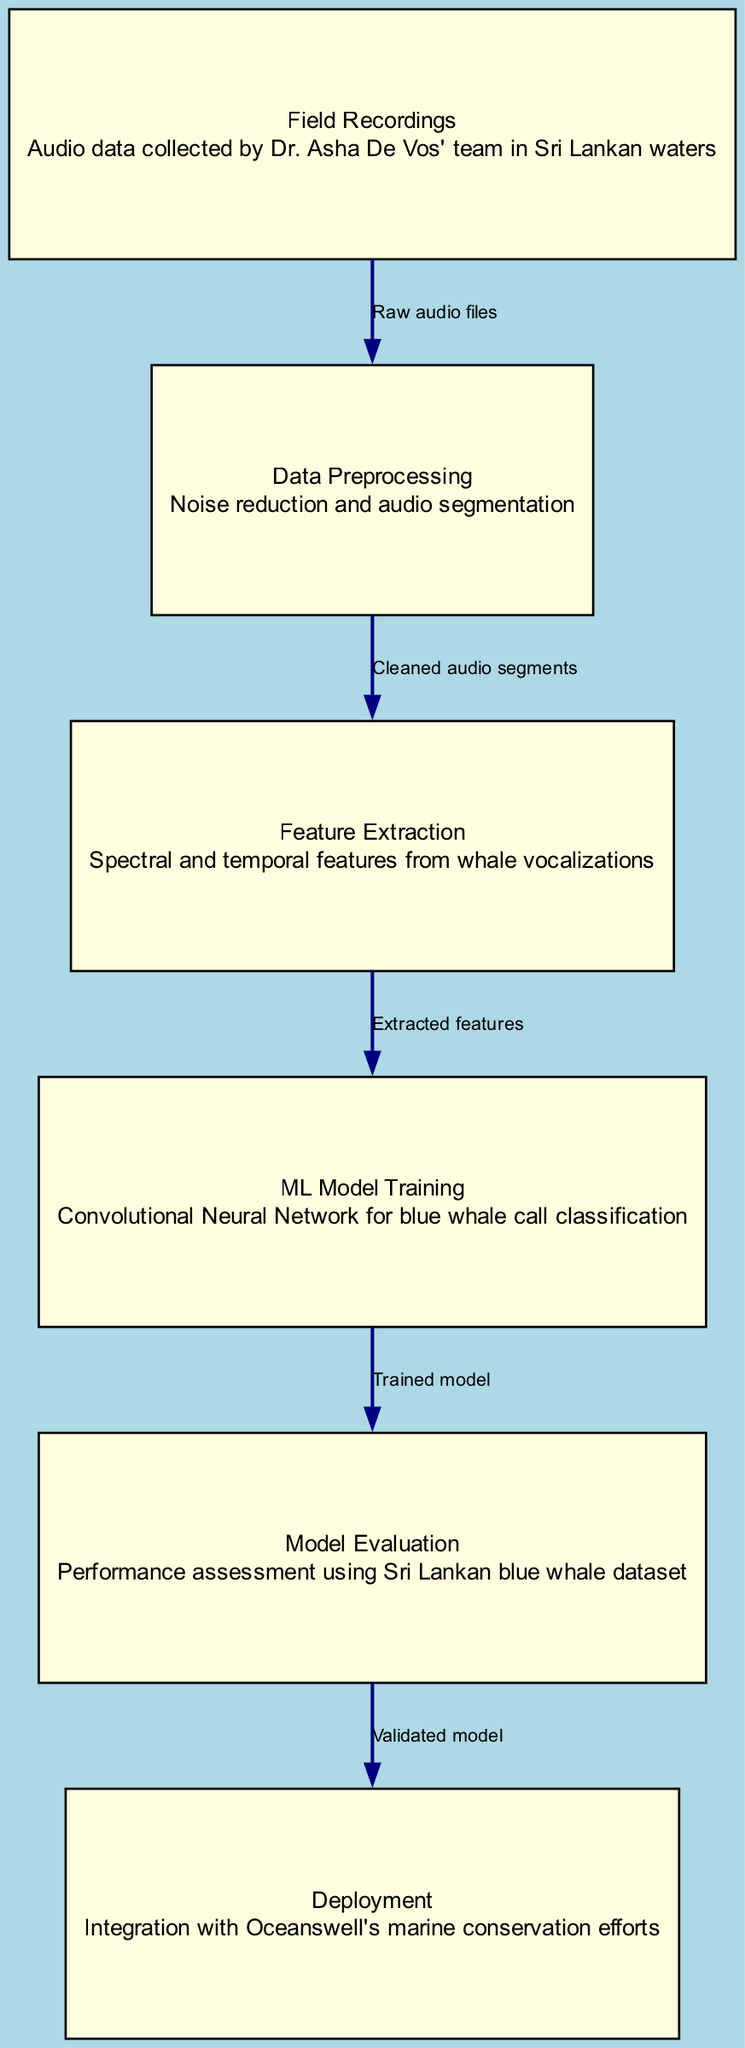What is the first step in the pipeline? The first step in the pipeline is indicated by the node at the top left, labeled "Field Recordings," which refers to the audio data collected by Dr. Asha De Vos' team.
Answer: Field Recordings How many nodes are in the diagram? By counting all the labeled boxes in the diagram, we find there are six distinct nodes representing different stages of the machine learning pipeline.
Answer: Six What type of model is used for training? The diagram indicates that a "Convolutional Neural Network" is utilized for training within the "ML Model Training" node.
Answer: Convolutional Neural Network What is the output of the Data Preprocessing node? The output of the Data Preprocessing node, which connects to Feature Extraction, is described as "Cleaned audio segments," indicating that this is the processed result from the previous node.
Answer: Cleaned audio segments What relationship exists between Model Evaluation and Deployment? The relationship is directed from Model Evaluation to Deployment, meaning that Model Evaluation leads to Deployment once a validated model has been obtained.
Answer: Validated model What technique is used to assess model performance? The explanation for model performance assessment can be found in the "Model Evaluation" node, which describes the performance assessment using the Sri Lankan blue whale dataset, indicating that this technique is the evaluation method.
Answer: Sri Lankan blue whale dataset How many edges connect the nodes in the diagram? By counting each line connecting the boxes in the diagram, we find there are five edges that depict the flow from one node to another in the pipeline.
Answer: Five Which node comes after Feature Extraction? The node that follows Feature Extraction in the progression of the pipeline, as per the directed connections, is labeled "ML Model Training," referring to the next step taken after features are extracted.
Answer: ML Model Training What is a key activity involved in Data Preprocessing? The description of the Data Preprocessing node includes activities such as "Noise reduction and audio segmentation," highlighting the critical function performed in this step.
Answer: Noise reduction and audio segmentation 